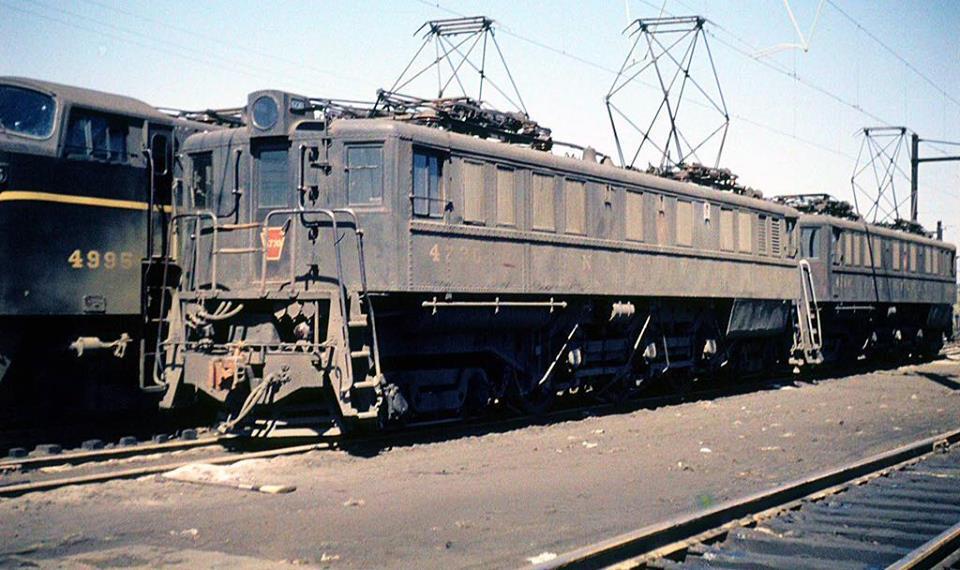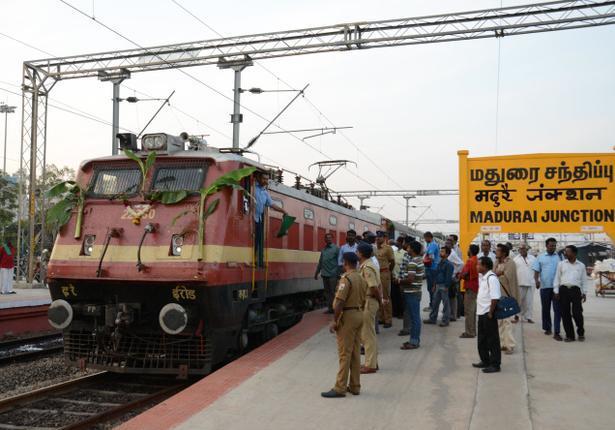The first image is the image on the left, the second image is the image on the right. Given the left and right images, does the statement "The right image shows a train with the front car colored red and yellow." hold true? Answer yes or no. Yes. 